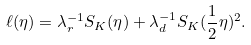Convert formula to latex. <formula><loc_0><loc_0><loc_500><loc_500>\ell ( \eta ) = \lambda _ { r } ^ { - 1 } S _ { K } ( \eta ) + \lambda _ { d } ^ { - 1 } S _ { K } ( \frac { 1 } { 2 } \eta ) ^ { 2 } .</formula> 